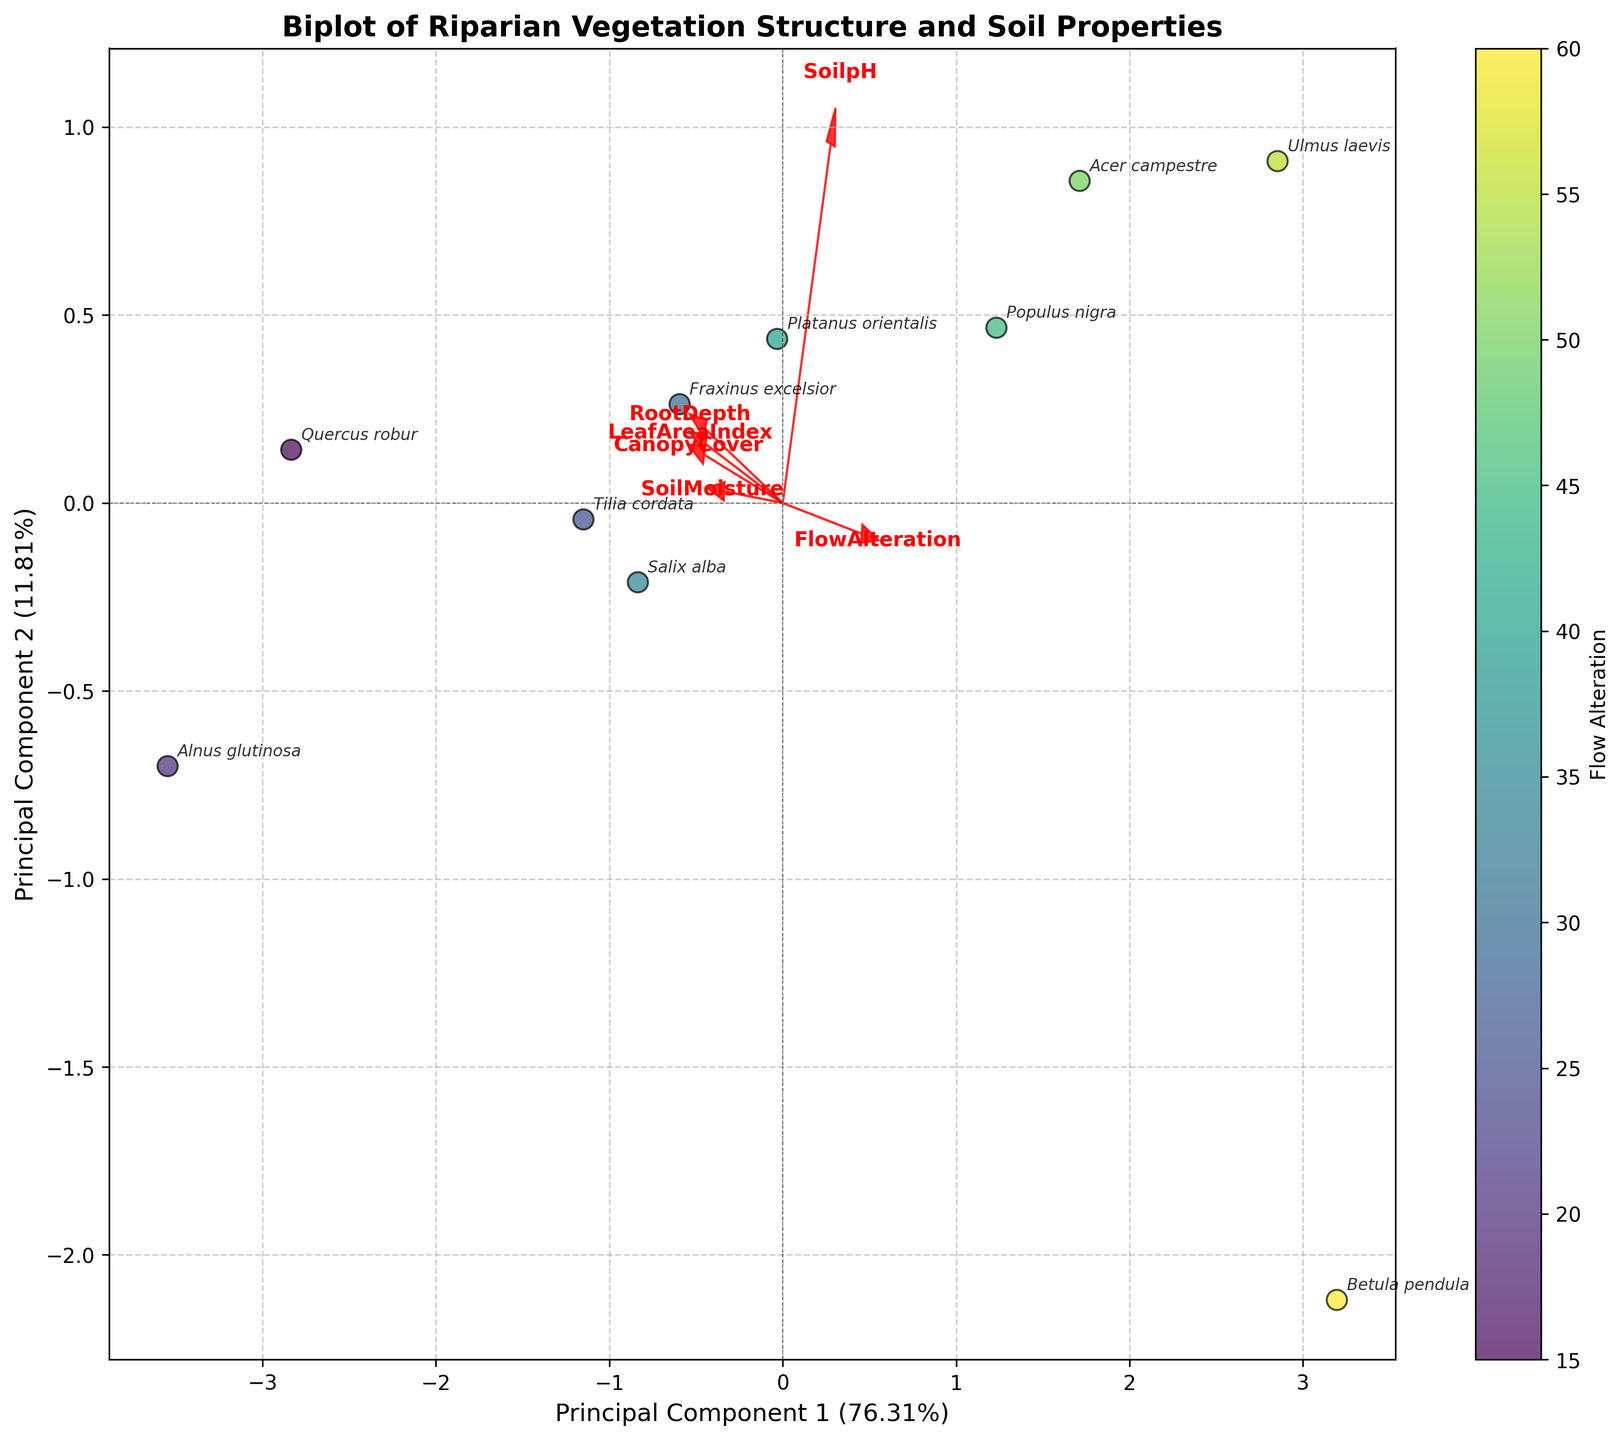What is the title of the biplot? The title of the biplot is usually displayed prominently at the top of the figure. It's written in larger and bold font and provides a summary of what the plot depicts.
Answer: Biplot of Riparian Vegetation Structure and Soil Properties Which principal component explains the most variance? The principal component that explains the most variance is shown on the x-axis or y-axis where the percentage value is higher. In the figure, check the percentages next to "Principal Component 1" and "Principal Component 2".
Answer: Principal Component 1 What is the percentage of variance explained by Principal Component 2? The percentage of variance explained by Principal Component 2 is typically written next to the label on the y-axis. In this case, look for the text next to "Principal Component 2" on the y-axis.
Answer: (Insert percentage here)% Which species is located closest to the origin? The species closest to the origin (0,0) can be identified by checking the points on the plot and determining which one is nearest to this central point.
Answer: (Insert species name here) How does canopy cover correlate with the two principal components? Look at the direction and length of the vector for "CanopyCover". The direction indicates the correlation with each principal component. A longer vector indicates a stronger correlation, and the angle from each axis indicates the strength and type of correlation (positive or negative).
Answer: (Insert observation about correlation here) Which feature vector has the steepest slope? To find the feature vector with the steepest slope, compare the angles of the vectors relative to the axes. The vector with the steepest angle relative to the horizontal or vertical axis has the steepest slope.
Answer: (Insert feature here) Between "Populus nigra" and "Betula pendula", which one has a higher flow alteration? Flow alteration can be inferred from the color map. Check the colors of "Populus nigra" and "Betula pendula" and compare their positions on the color scale bar to determine which is higher.
Answer: (Insert species name here) What is the relationship between soil pH and canopy cover? Examine the directions of the "SoilpH" and "CanopyCover" vectors. If they point in similar directions, there's a positive correlation. If they point in opposite directions, there's a negative correlation.
Answer: (Insert relationship here) Which species has the highest canopy cover and where is it located on the plot? Identify the "CanopyCover" values from the data and locate the species with the highest value. Check this species' position on the plot.
Answer: (Insert species name and location here) 